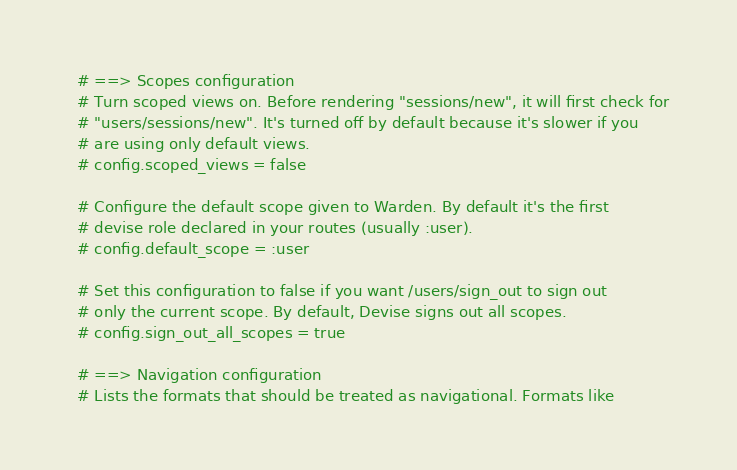<code> <loc_0><loc_0><loc_500><loc_500><_Ruby_>  # ==> Scopes configuration
  # Turn scoped views on. Before rendering "sessions/new", it will first check for
  # "users/sessions/new". It's turned off by default because it's slower if you
  # are using only default views.
  # config.scoped_views = false

  # Configure the default scope given to Warden. By default it's the first
  # devise role declared in your routes (usually :user).
  # config.default_scope = :user

  # Set this configuration to false if you want /users/sign_out to sign out
  # only the current scope. By default, Devise signs out all scopes.
  # config.sign_out_all_scopes = true

  # ==> Navigation configuration
  # Lists the formats that should be treated as navigational. Formats like</code> 